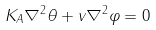Convert formula to latex. <formula><loc_0><loc_0><loc_500><loc_500>K _ { A } \nabla ^ { 2 } \theta + v \nabla ^ { 2 } \varphi = 0</formula> 